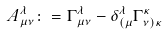<formula> <loc_0><loc_0><loc_500><loc_500>A ^ { \lambda } _ { \mu \nu } \colon = { \Gamma } ^ { \lambda } _ { \mu \nu } - { \delta } ^ { \lambda } _ { ( \mu } { \Gamma } ^ { \kappa } _ { \nu ) \kappa }</formula> 